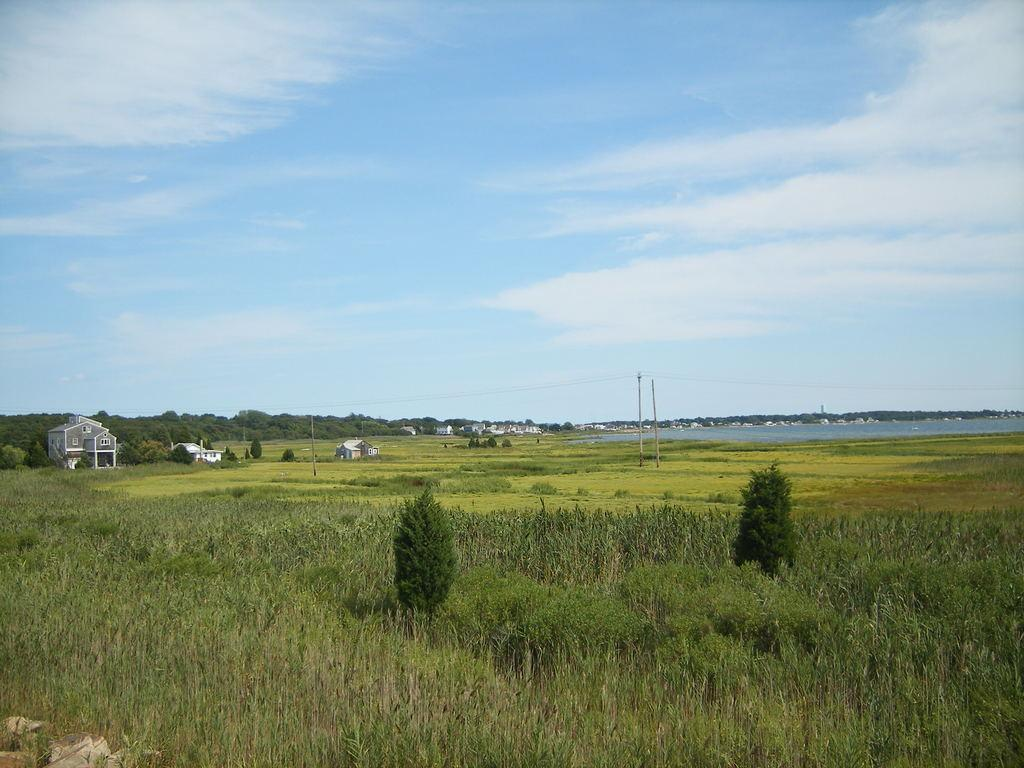What type of vegetation can be seen in the image? There is grass and plants visible in the image. What structures are present in the image? There are poles and houses visible in the image. What natural element can be seen in the image? There is water visible in the image. What type of vegetation is present in the image? There are trees visible in the image. What is visible in the background of the image? The sky is visible in the background of the image. What can be seen in the sky? There are clouds visible in the sky. Can you tell me how many times the person in the image offers their wrist for inspection? There is no person visible in the image, so it is not possible to determine if they offer their wrist for inspection. 